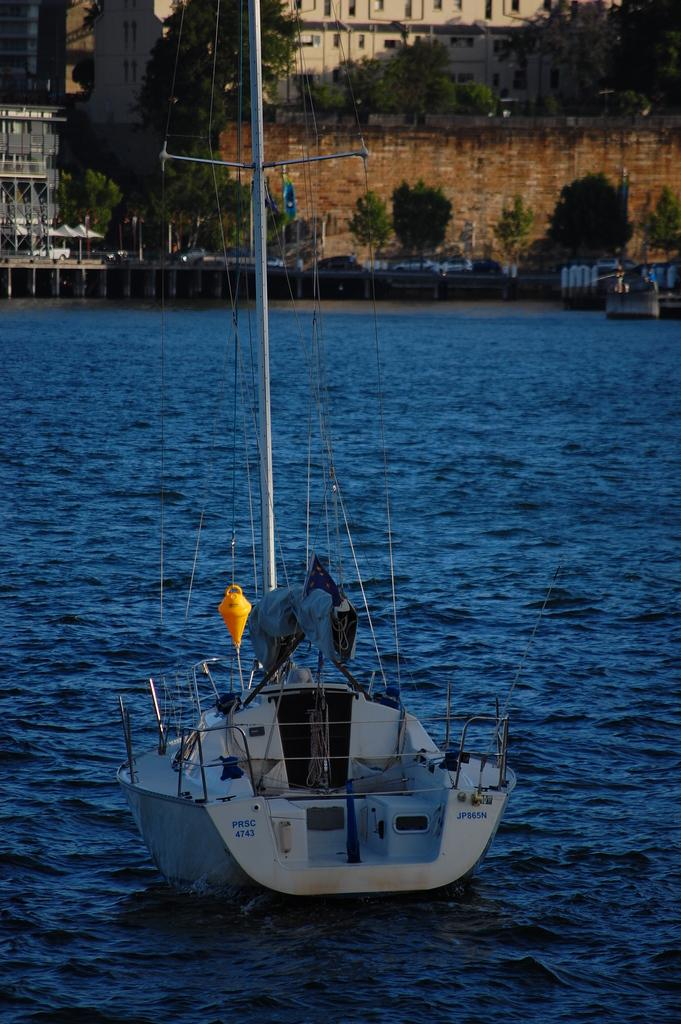What is the main subject in the foreground of the image? There is a boat in the foreground of the image. What is the boat's location in relation to the water? The boat is on the water. What can be seen in the background of the image? There are buildings, trees, and a bridge in the background of the image. Is the water visible in the image? Yes, the water is visible in the image. What type of vest is the fowl wearing in the image? There is no fowl or vest present in the image. How does the throat of the boat affect its performance in the water? The boat does not have a throat, so this question cannot be answered. 